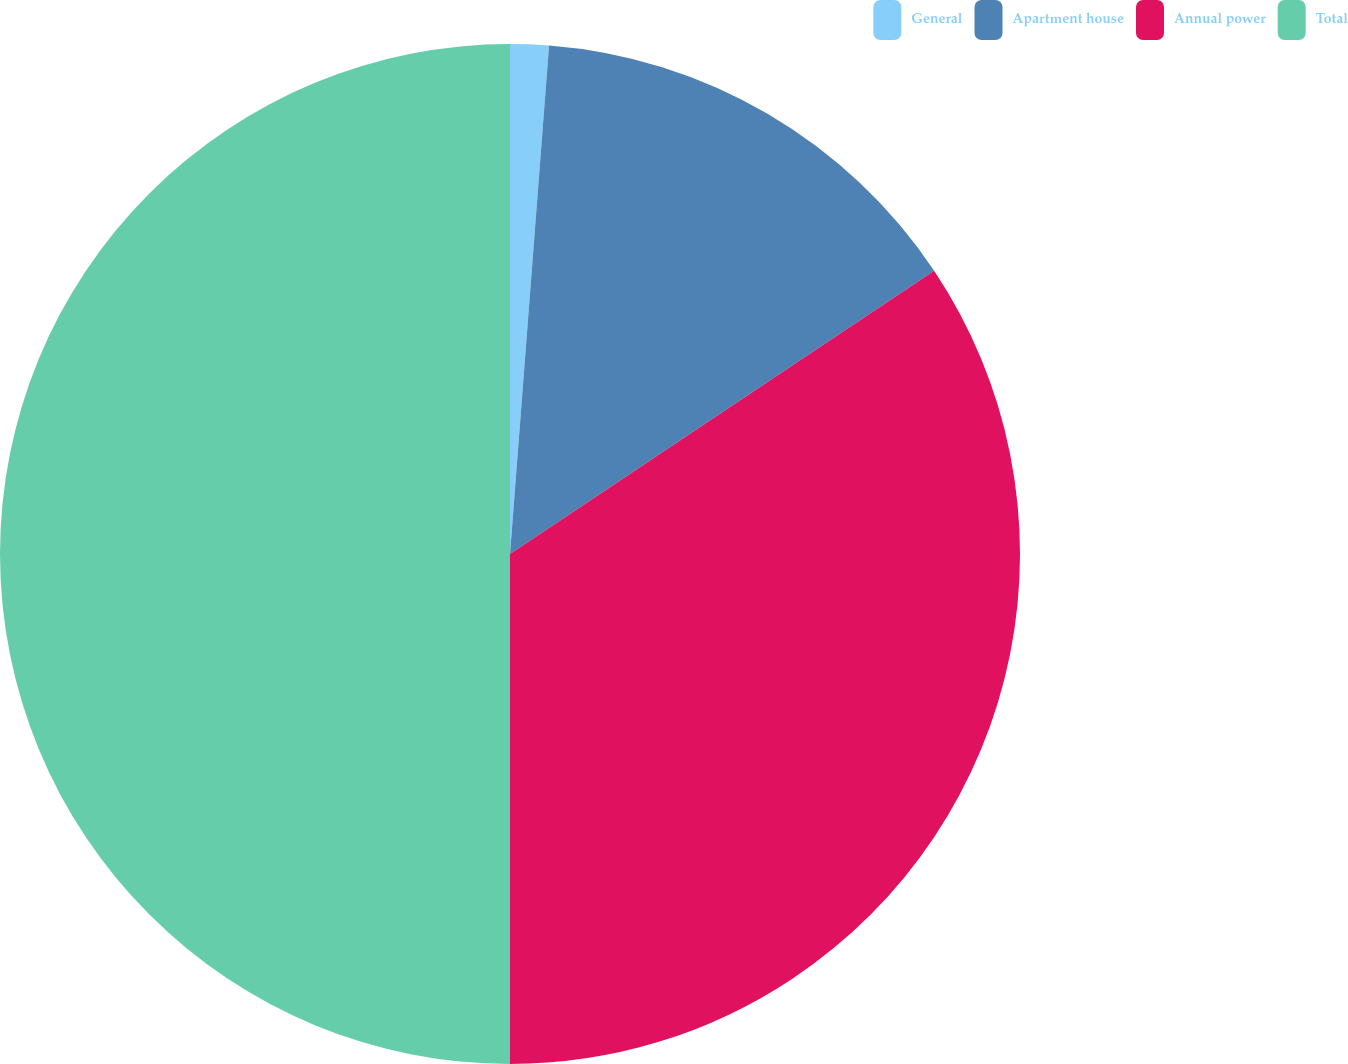Convert chart to OTSL. <chart><loc_0><loc_0><loc_500><loc_500><pie_chart><fcel>General<fcel>Apartment house<fcel>Annual power<fcel>Total<nl><fcel>1.22%<fcel>14.41%<fcel>34.37%<fcel>50.0%<nl></chart> 